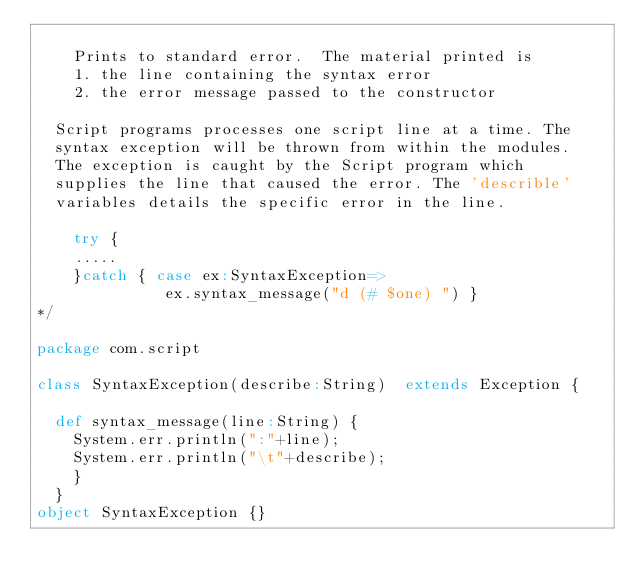<code> <loc_0><loc_0><loc_500><loc_500><_Scala_>
		Prints to standard error.  The material printed is
		1. the line containing the syntax error
		2. the error message passed to the constructor

	Script programs processes one script line at a time. The 
	syntax exception will be thrown from within the modules.
	The exception is caught by the Script program which
	supplies the line that caused the error. The 'describle'
	variables details the specific error in the line. 

		try {
		.....
		}catch { case ex:SyntaxException=> 
							ex.syntax_message("d (# $one) ") }
*/

package com.script

class SyntaxException(describe:String)  extends Exception {
	
	def syntax_message(line:String) { 
		System.err.println(":"+line);
		System.err.println("\t"+describe); 
		}
	}
object SyntaxException {}


</code> 